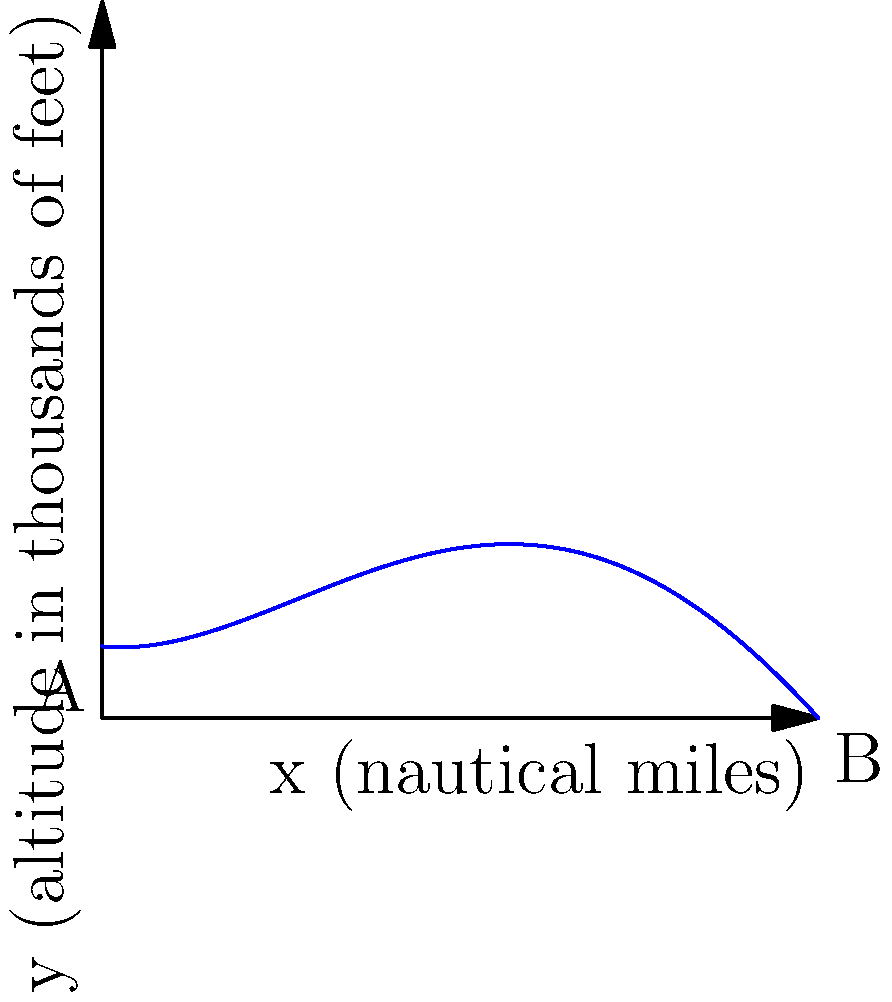The graph represents the flight path of an aircraft during an evasive maneuver, modeled by the fourth-degree polynomial function $f(x) = 0.001x^4 - 0.03x^3 + 0.2x^2 - 0.1x + 1$, where $x$ is the horizontal distance in nautical miles and $f(x)$ is the altitude in thousands of feet. At what point along the horizontal distance does the aircraft reach its minimum altitude during this maneuver? To find the minimum altitude, we need to determine where the derivative of the function equals zero:

1) First, calculate the derivative:
   $f'(x) = 0.004x^3 - 0.09x^2 + 0.4x - 0.1$

2) Set the derivative equal to zero:
   $0.004x^3 - 0.09x^2 + 0.4x - 0.1 = 0$

3) This cubic equation can be solved using numerical methods or a graphing calculator. The solutions are approximately:
   $x \approx 0.26$, $x \approx 5.62$, and $x \approx 16.62$

4) Since we're only considering the range from 0 to 10 nautical miles (as shown in the graph), we can discard the solution $x \approx 16.62$.

5) To determine which of the remaining solutions corresponds to the minimum, we can check the second derivative:
   $f''(x) = 0.012x^2 - 0.18x + 0.4$

6) Evaluating $f''(0.26) \approx 0.35 > 0$, indicating a local minimum.
   Evaluating $f''(5.62) \approx -0.07 < 0$, indicating a local maximum.

Therefore, the minimum altitude occurs at approximately 0.26 nautical miles along the horizontal distance.
Answer: 0.26 nautical miles 